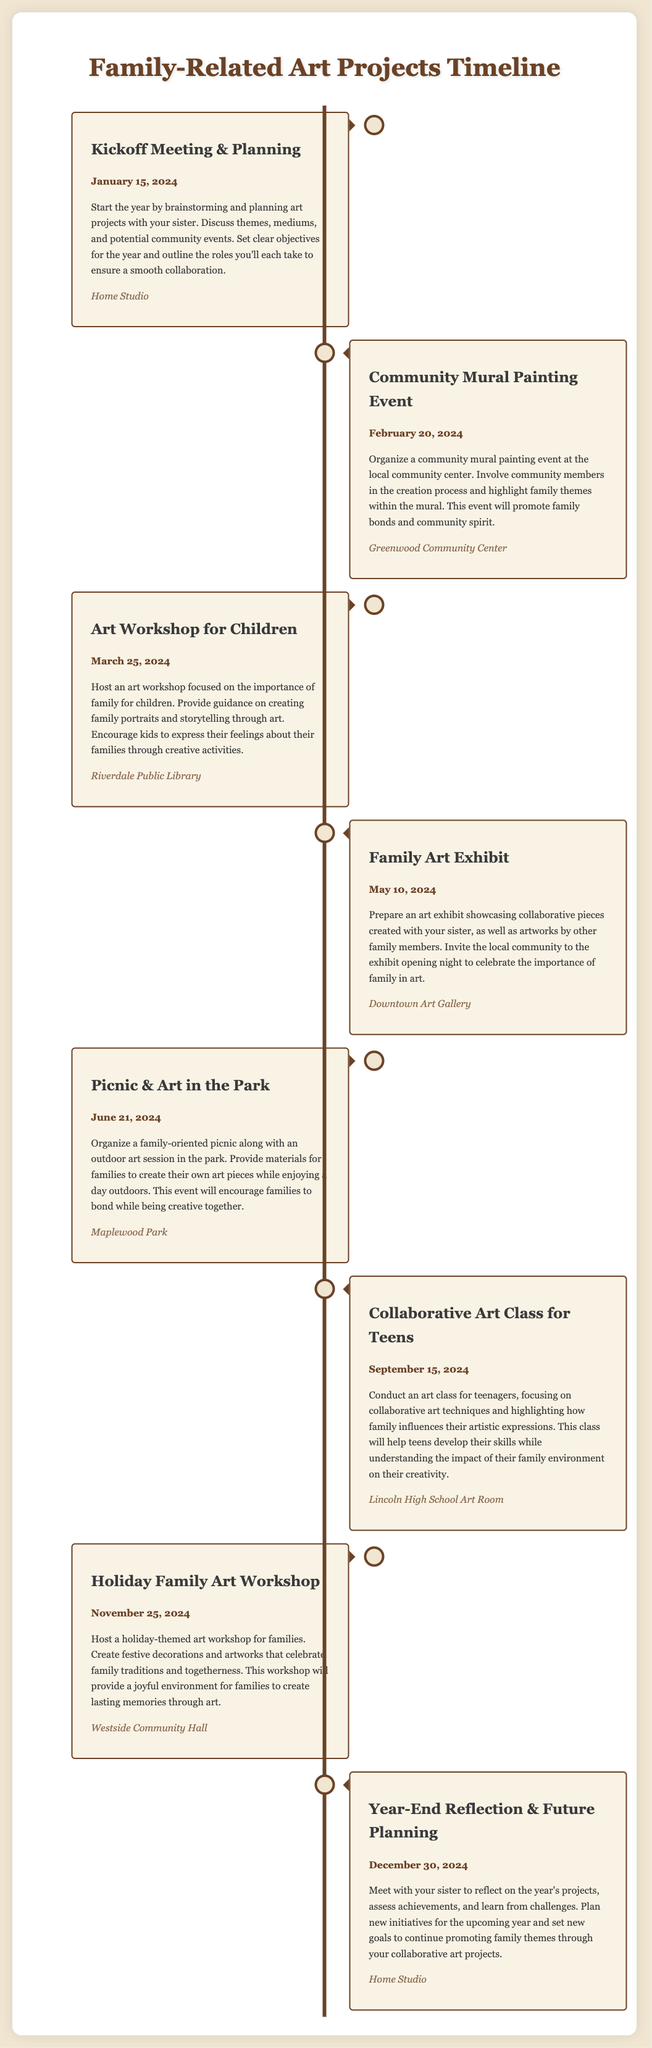What is the date of the kickoff meeting? The document states that the kickoff meeting is scheduled for January 15, 2024.
Answer: January 15, 2024 Where will the family art exhibit take place? The document specifies that the family art exhibit will be held at the Downtown Art Gallery.
Answer: Downtown Art Gallery What is the theme of the art workshop for children? The document mentions that the workshop for children focuses on the importance of family.
Answer: Importance of family On what date is the picnic & art in the park event planned? According to the document, the picnic and art in the park event is planned for June 21, 2024.
Answer: June 21, 2024 Which community center will host the community mural painting event? The community mural painting event is organized at the Greenwood Community Center as mentioned in the document.
Answer: Greenwood Community Center What are the goals for the year-end reflection meeting? The document outlines the purpose of the year-end meeting as reflecting on projects and planning for new initiatives.
Answer: Reflecting on projects and planning for new initiatives What type of class is scheduled for September 15, 2024? It is specified in the document that a collaborative art class for teens is scheduled on that date.
Answer: Collaborative art class for teens How will the holiday family art workshop help families? The document states that this workshop will provide a joyful environment for families to create lasting memories through art.
Answer: Create lasting memories through art 